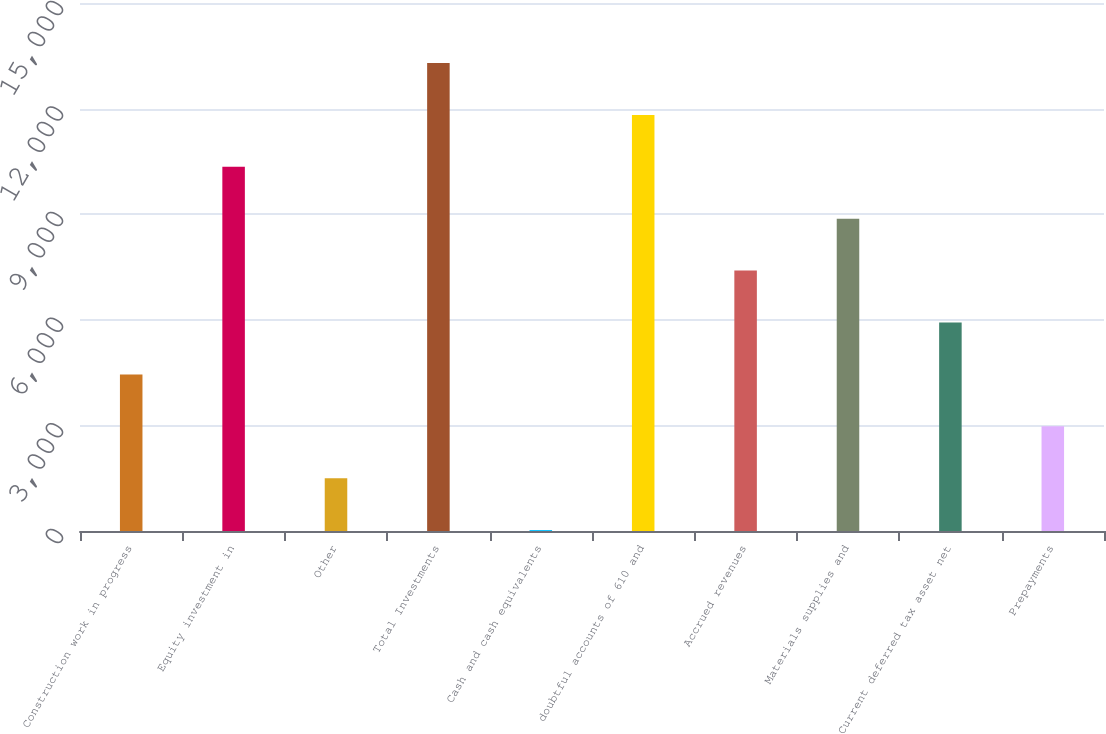<chart> <loc_0><loc_0><loc_500><loc_500><bar_chart><fcel>Construction work in progress<fcel>Equity investment in<fcel>Other<fcel>Total Investments<fcel>Cash and cash equivalents<fcel>doubtful accounts of 610 and<fcel>Accrued revenues<fcel>Materials supplies and<fcel>Current deferred tax asset net<fcel>Prepayments<nl><fcel>4449.02<fcel>10346.4<fcel>1500.34<fcel>13295.1<fcel>26<fcel>11820.7<fcel>7397.7<fcel>8872.04<fcel>5923.36<fcel>2974.68<nl></chart> 